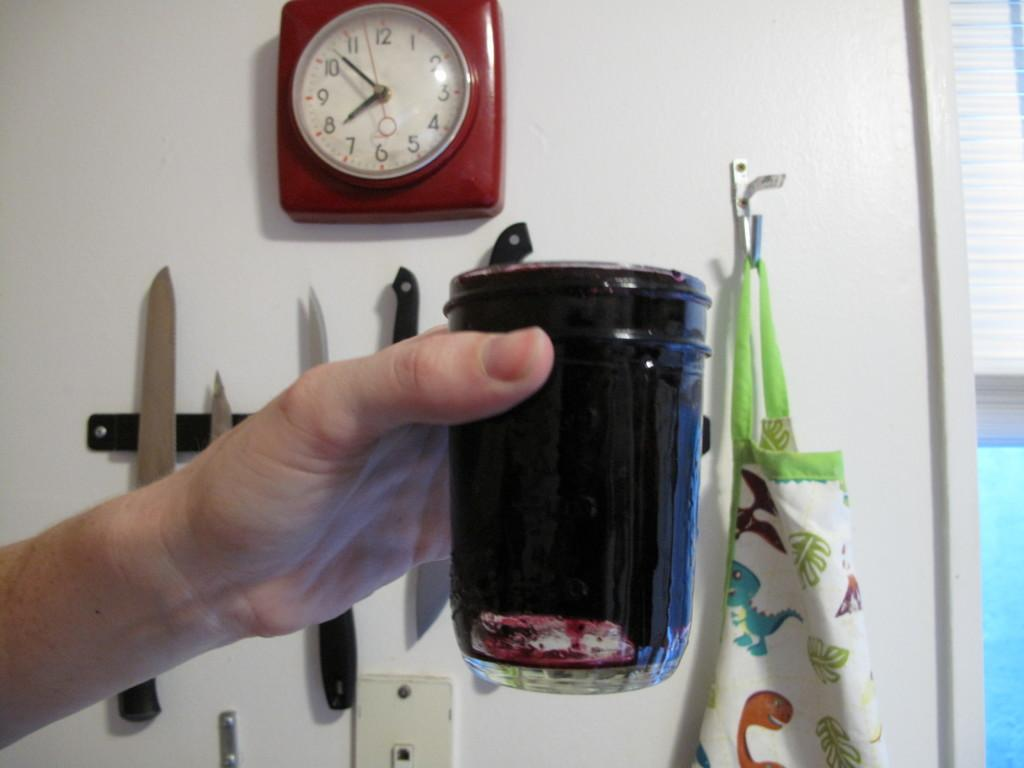<image>
Provide a brief description of the given image. A hand holding up a glass full of a dark liquid with a clock that reads 8:53 on its face. 